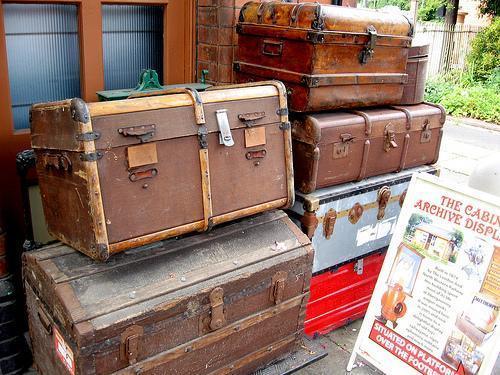How many trunks are visible in this photo?
Give a very brief answer. 7. 